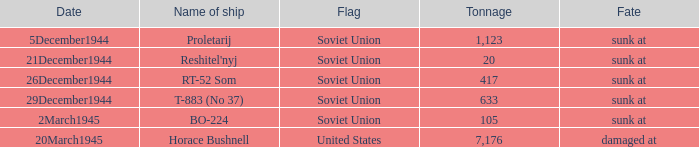What is the usual tonnage for the proletarij ship? 1123.0. 